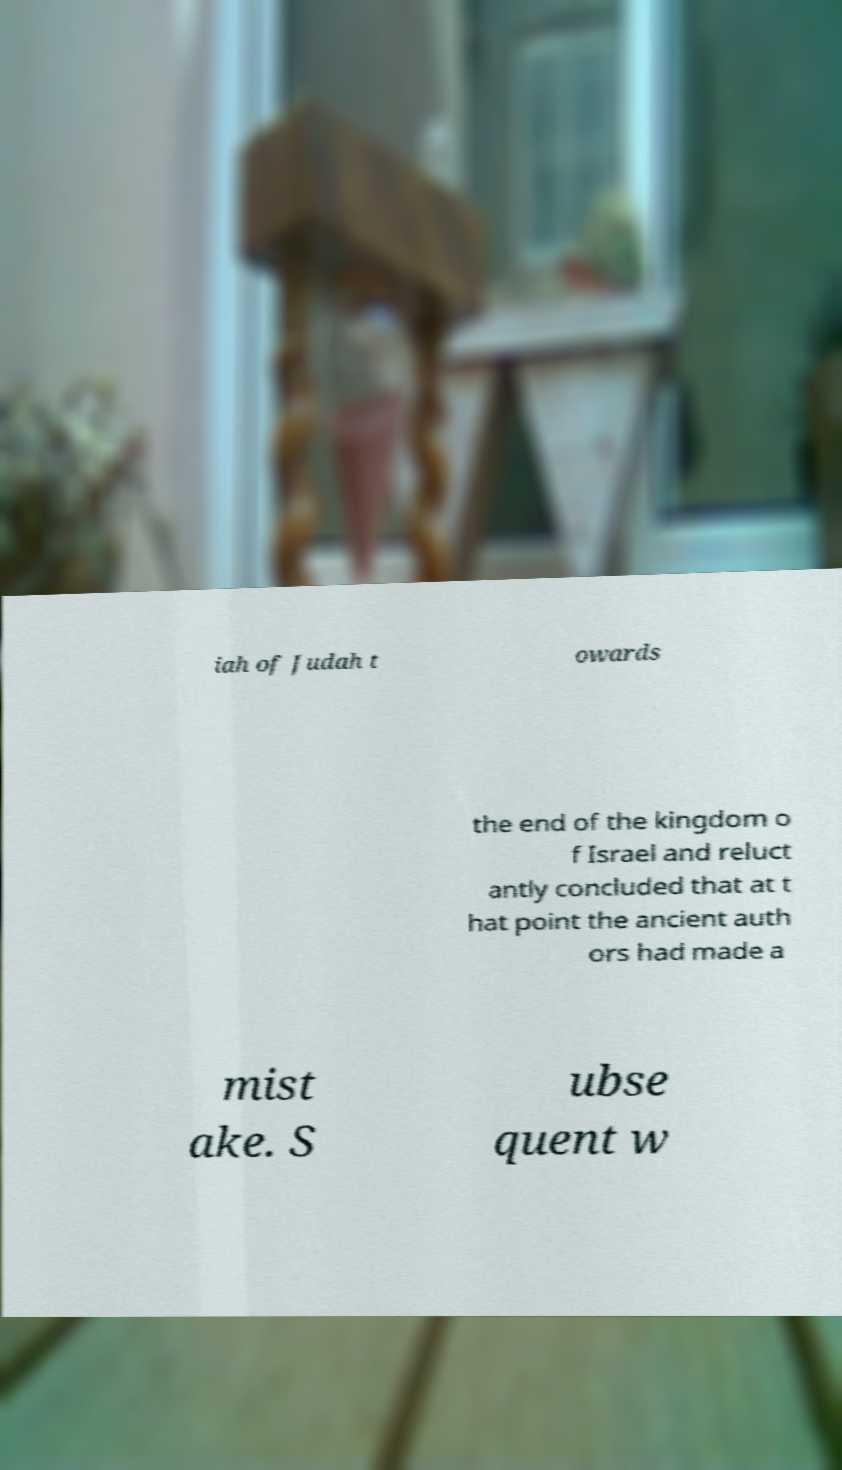Can you read and provide the text displayed in the image?This photo seems to have some interesting text. Can you extract and type it out for me? iah of Judah t owards the end of the kingdom o f Israel and reluct antly concluded that at t hat point the ancient auth ors had made a mist ake. S ubse quent w 